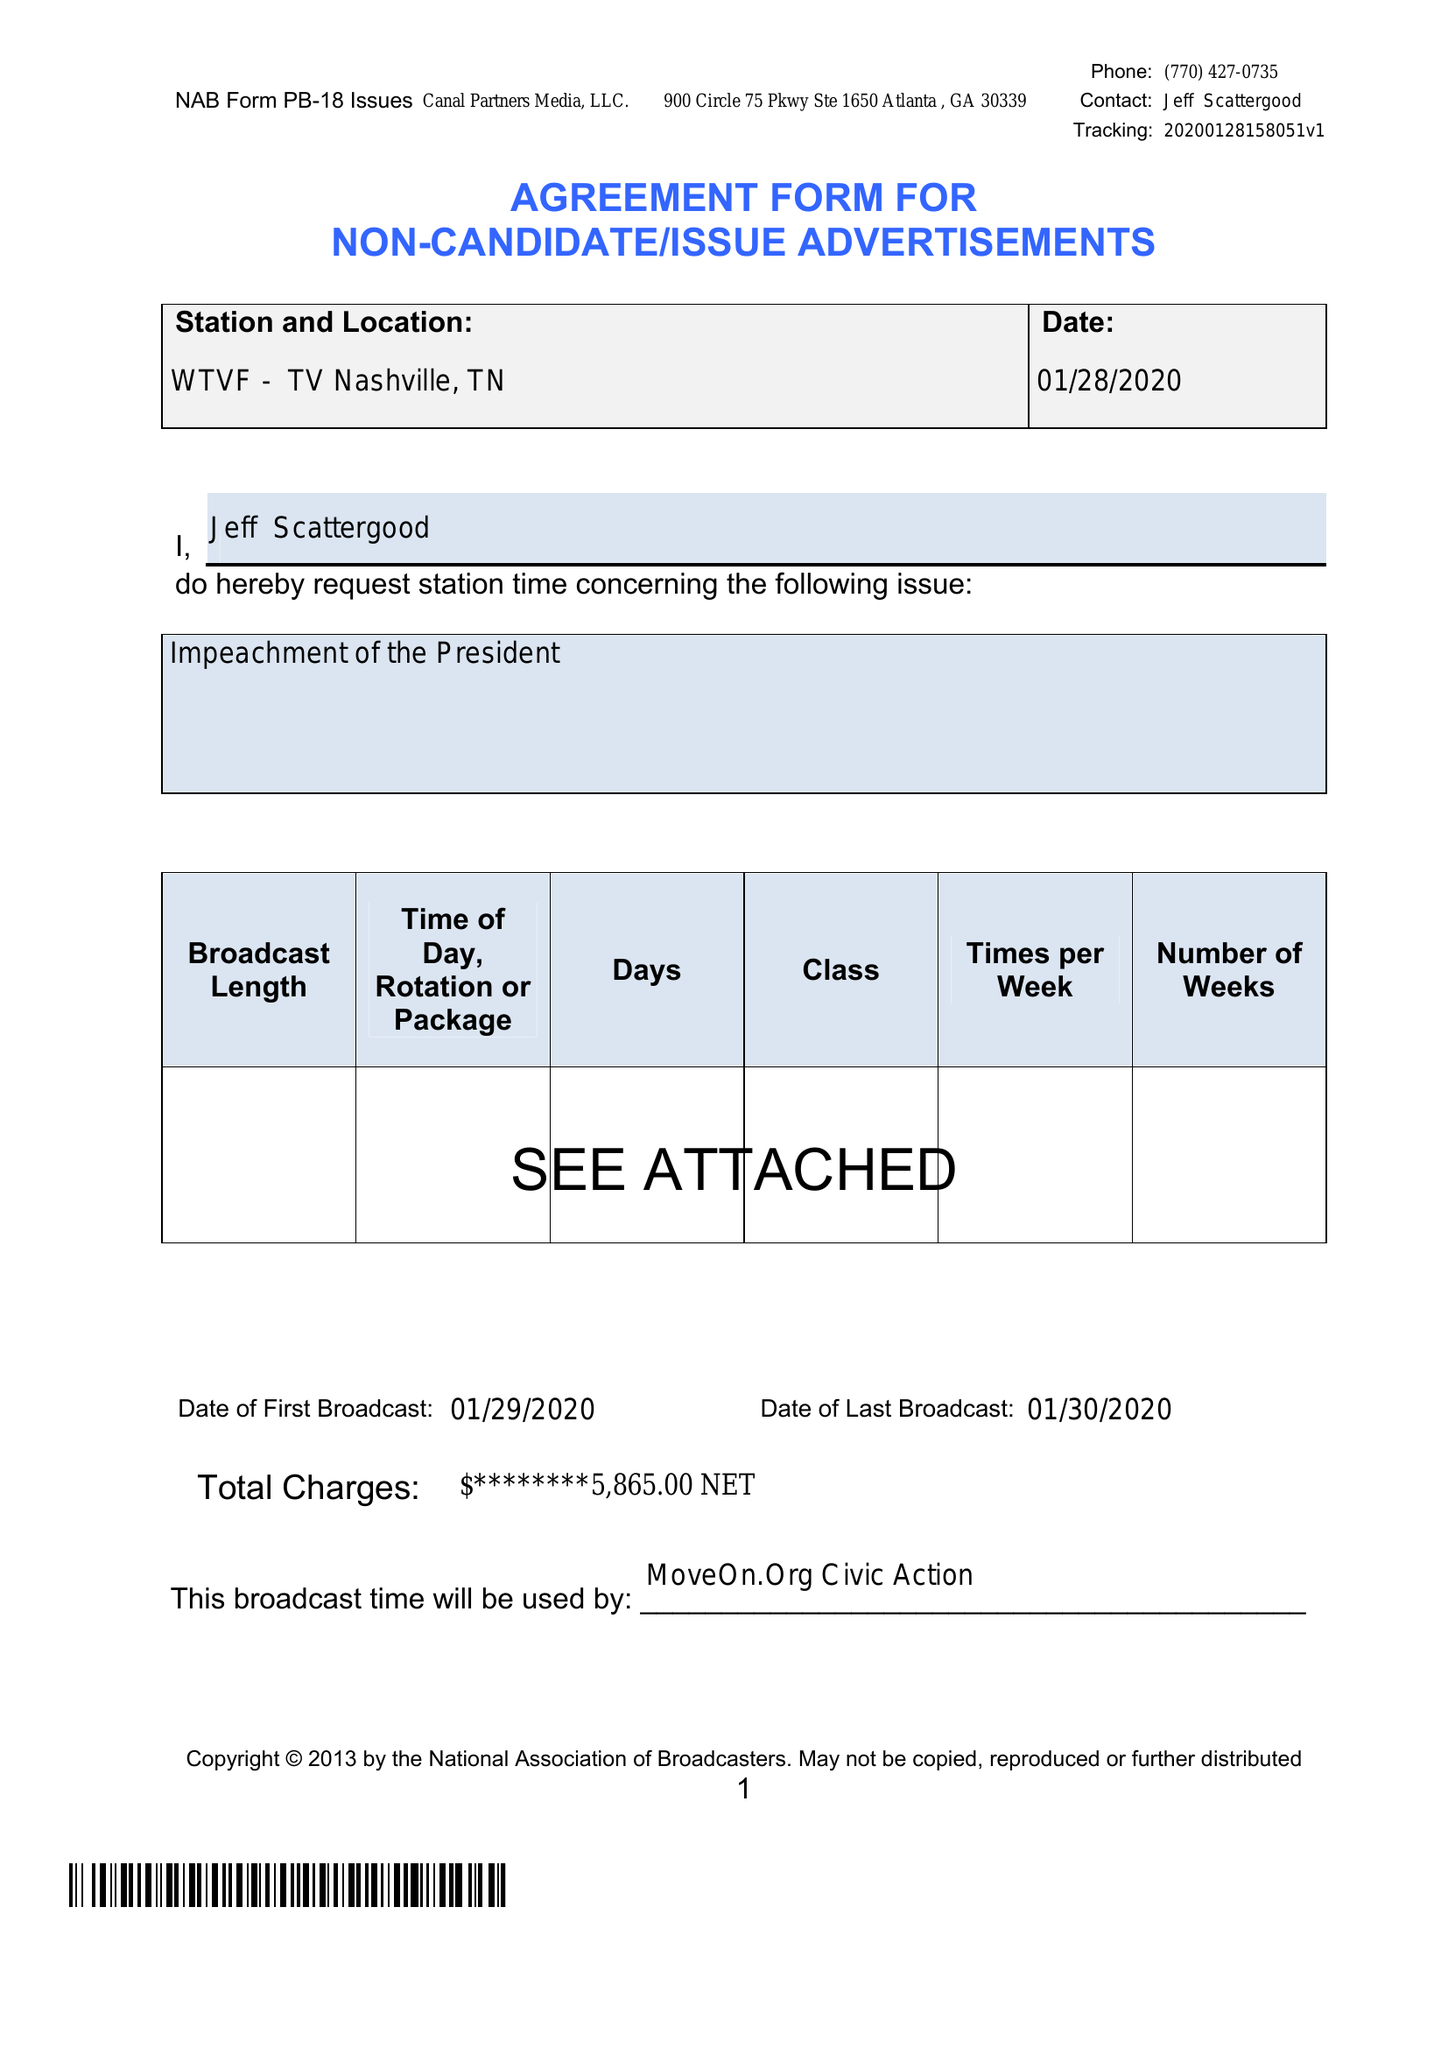What is the value for the gross_amount?
Answer the question using a single word or phrase. None 